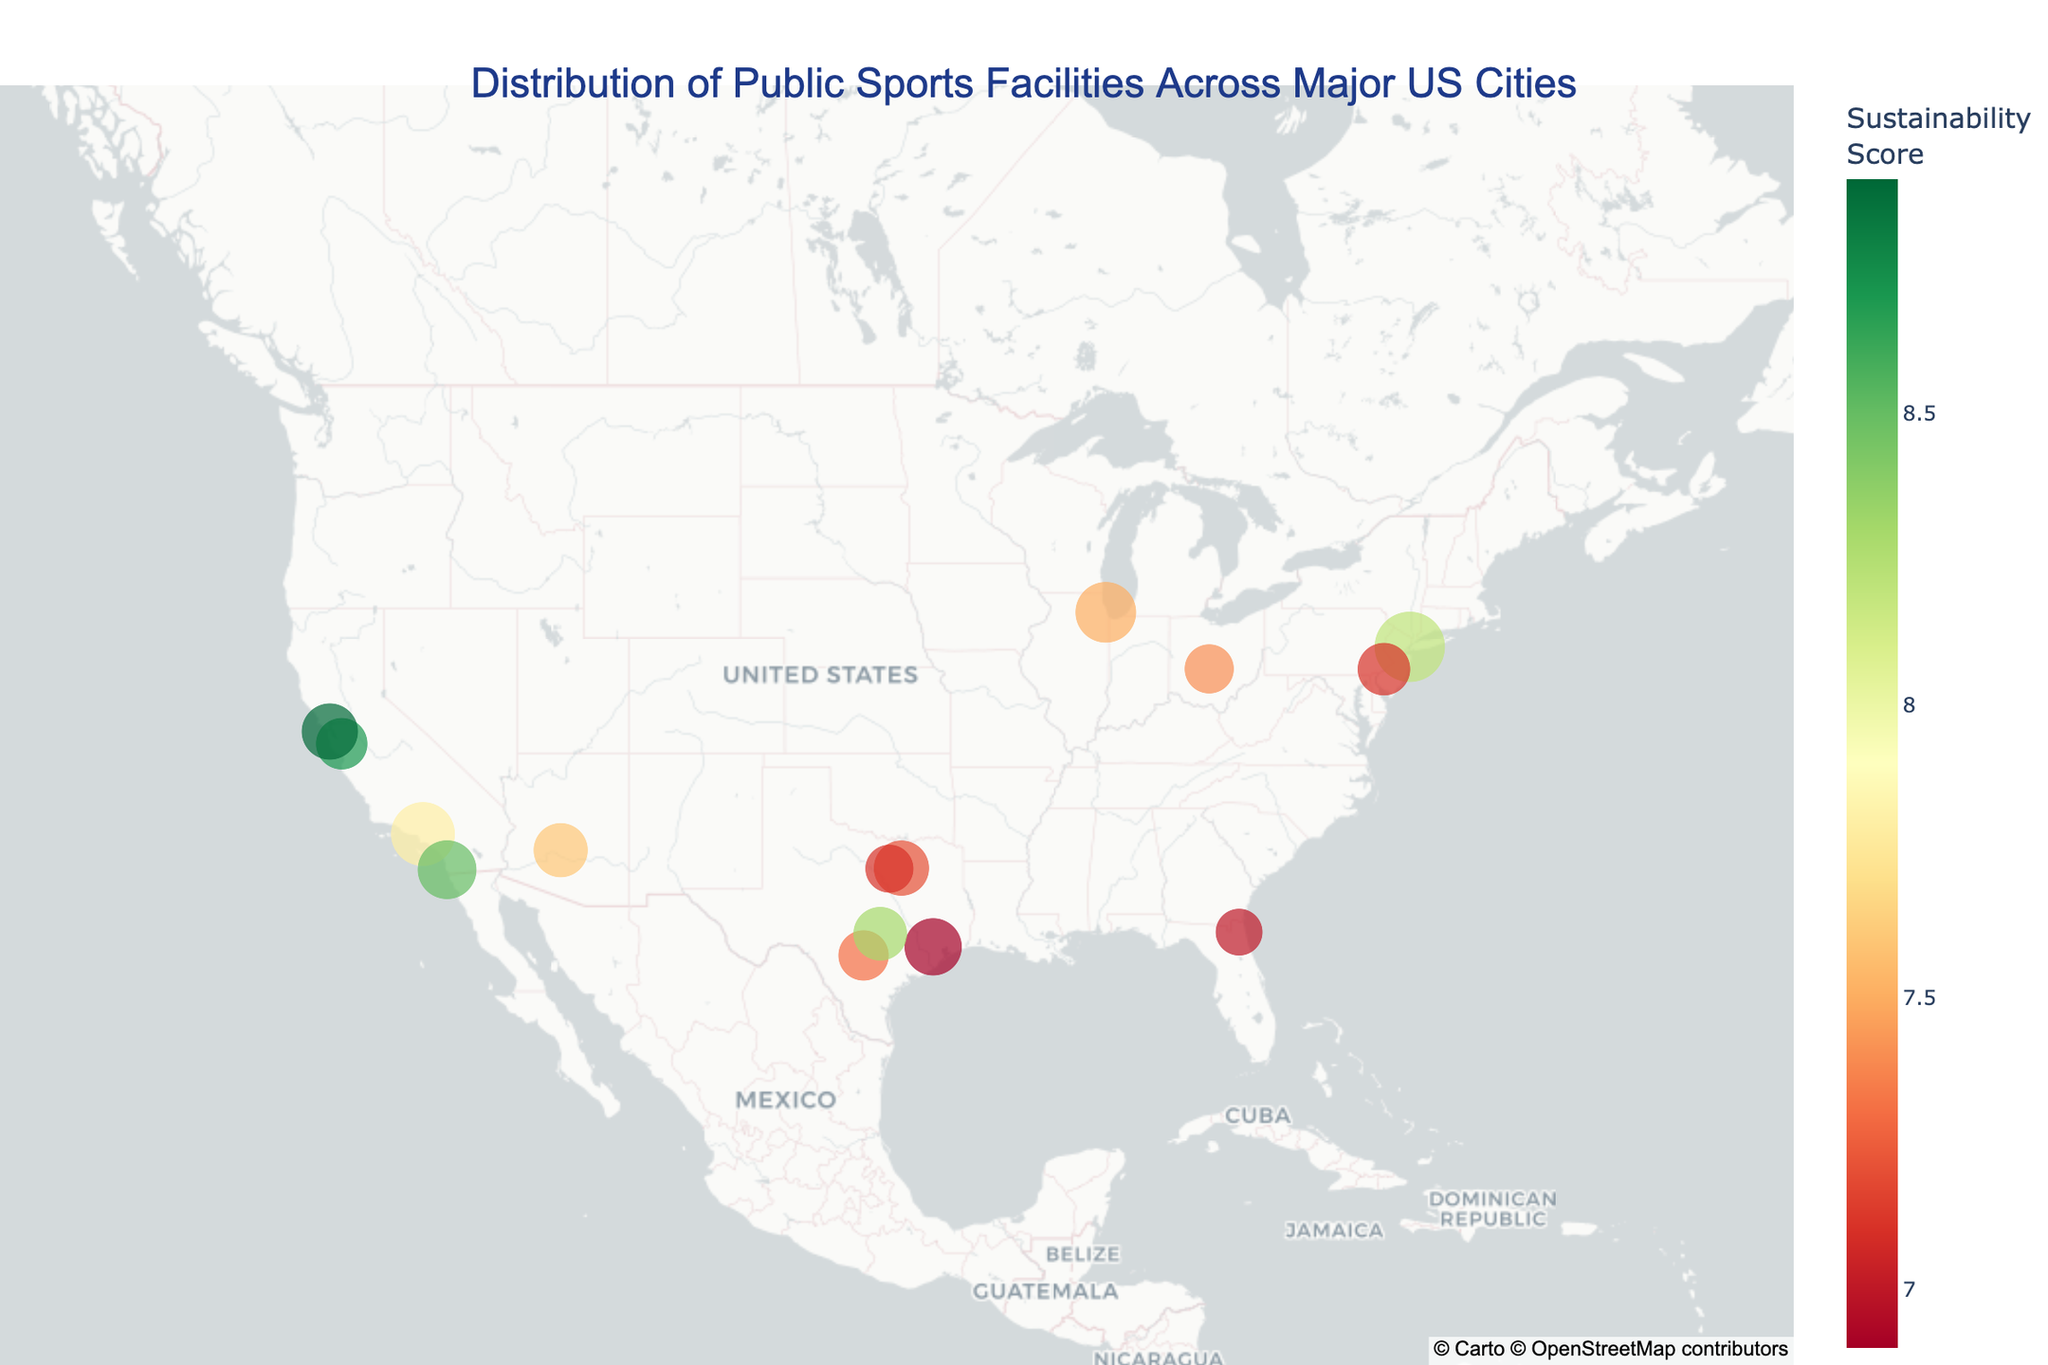What is the title of the map? The title is located at the top of the map, displayed in a larger font size and centered horizontally.
Answer: Distribution of Public Sports Facilities Across Major US Cities Which city has the highest number of public sports facilities? The size of the markers corresponds to the number of public sports facilities. The largest marker identifies the city with the highest count.
Answer: New York What city has the highest sustainability score? Look for the city with the darkest green colored marker, indicating the highest sustainability score according to the color scale.
Answer: San Francisco Which cities have both the highest sustainability and accessibility scores? Cross-reference the cities with dark green markers for high sustainability scores and the highest custom data (accessibility scores) seen when hovering over the markers.
Answer: San Francisco and San Diego How many public sports facilities are there in Philadelphia? Hover over the marker on Philadelphia; the tooltip will display "Public Sports Facilities: 49".
Answer: 49 Which city among New York, Los Angeles, and Houston has the highest accessibility score? Hover over each marker to find their accessibility scores; compare them to identify the highest score.
Answer: Chicago What is the average sustainability score for San Diego, San Jose, and Austin? Locate these cities, hover to find their sustainability scores, add them up and divide by three: (8.5 + 8.7 + 8.3)/3 = 8.5.
Answer: 8.5 Which city has the smallest number of public sports facilities but still a high sustainability score? Identify markers with smaller sizes and darker green hues, hover over to confirm the sustainability scores.
Answer: Jacksonville How are the cities spatially distributed based on their sustainability score? Observe the markers' color distribution on the map to describe how cities with various sustainability scores are positioned relative to each other across the country.
Answer: Cities with higher sustainability scores tend to be on the coasts and more spatially dispersed Which city has the most balanced score in sustainability and accessibility? Look for cities where both sustainability and accessibility scores are high and close in value; this requires evaluating custom data and color shades for markers.
Answer: Chicago 